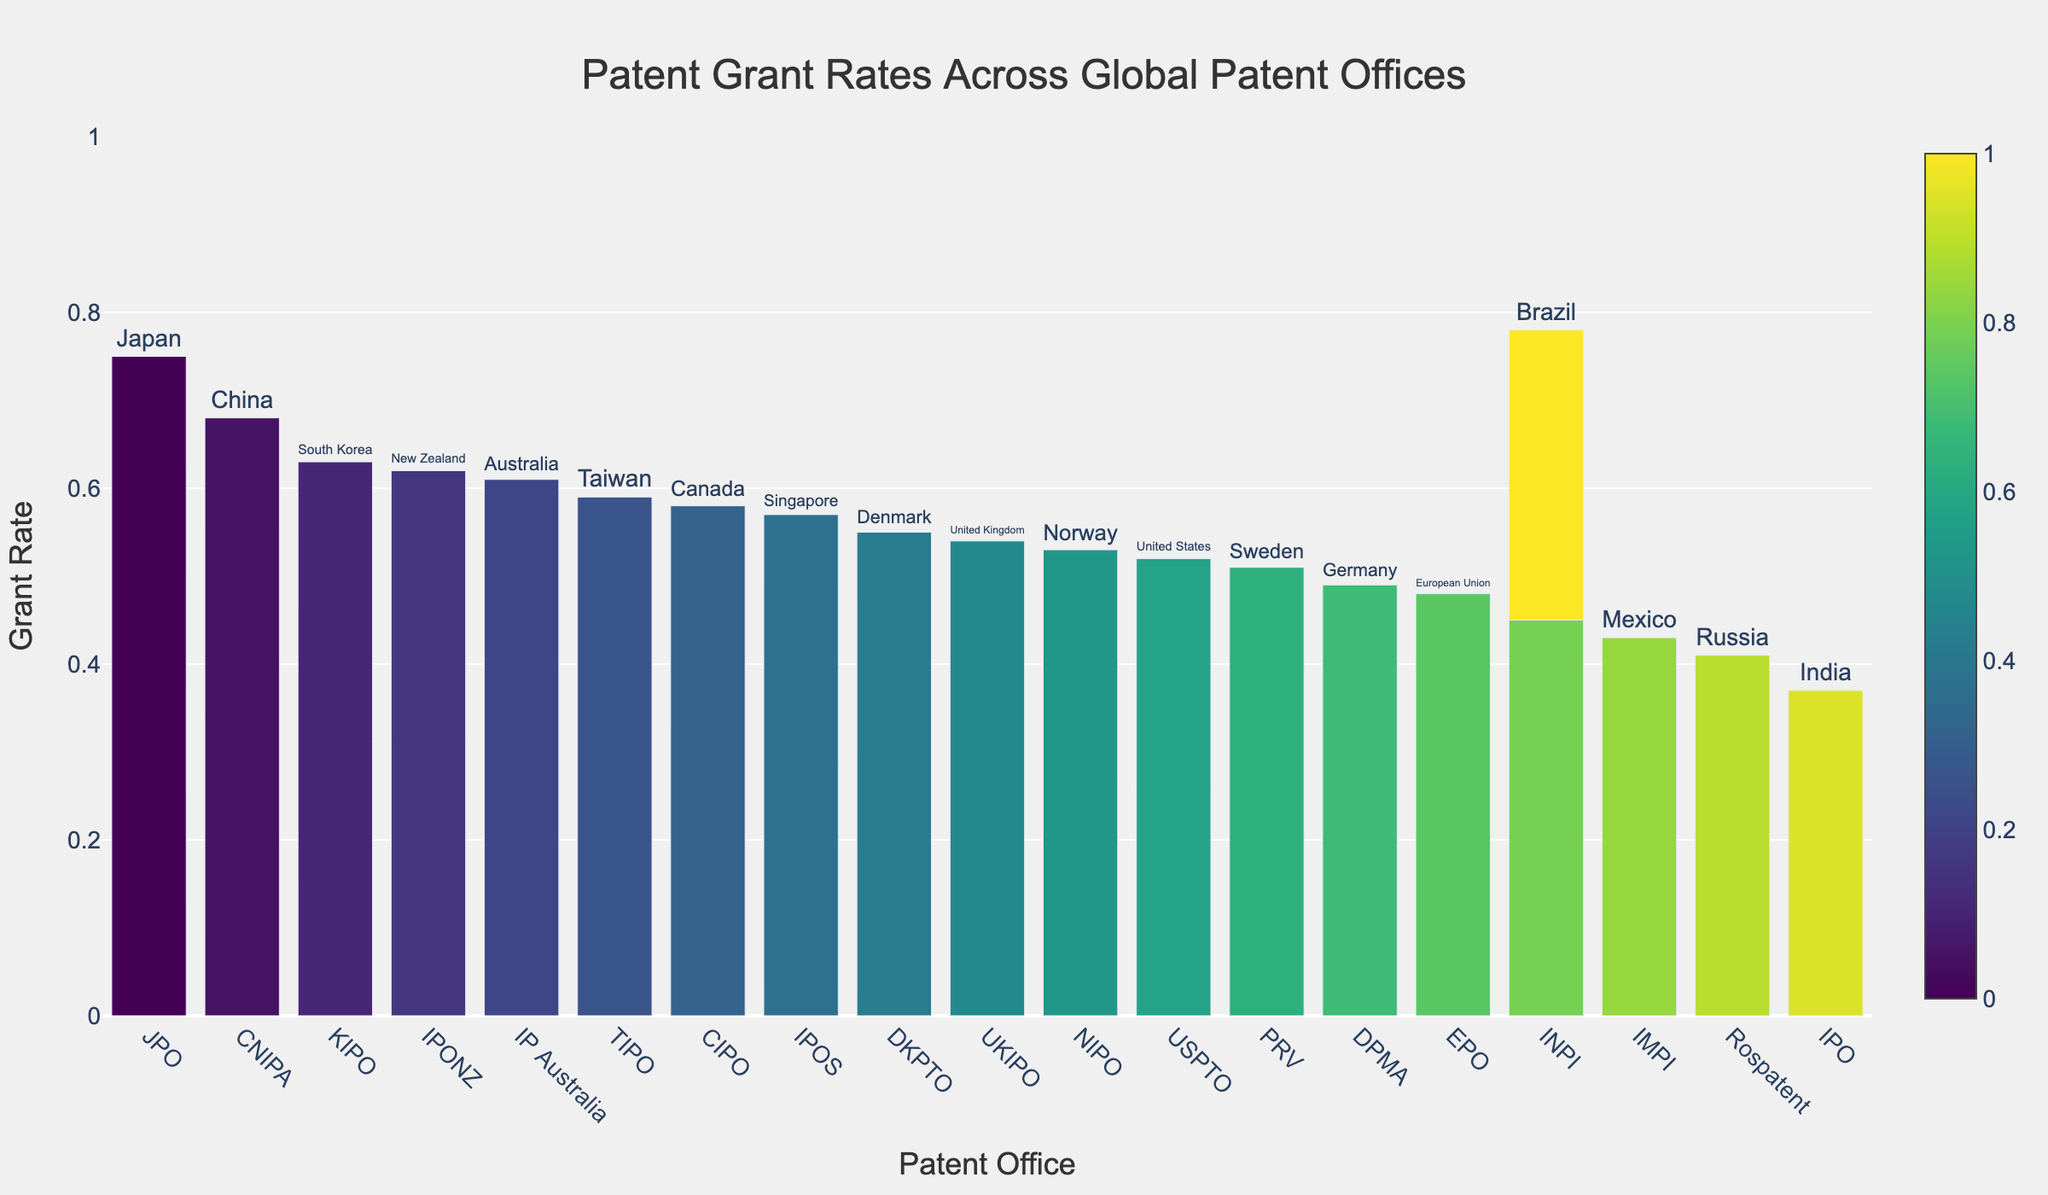Which patent office has the highest grant rate? To find this, locate the tallest bar in the plot, which represents the patent office with the highest grant rate.
Answer: JPO, Japan What's the grant rate for USPTO in the United States? Find the bar labeled as "USPTO" and read the value of the grant rate next to it.
Answer: 0.52 Which country has the lowest grant rate and what is it? Identify the shortest bar in the plot, which indicates the country with the lowest grant rate.
Answer: INPI, Brazil; 0.33 Which three patent offices have a grant rate above 0.60? Identify the bars taller than the 0.60 mark and list their labels.
Answer: JPO, Japan; CNIPA, China; KIPO, South Korea 